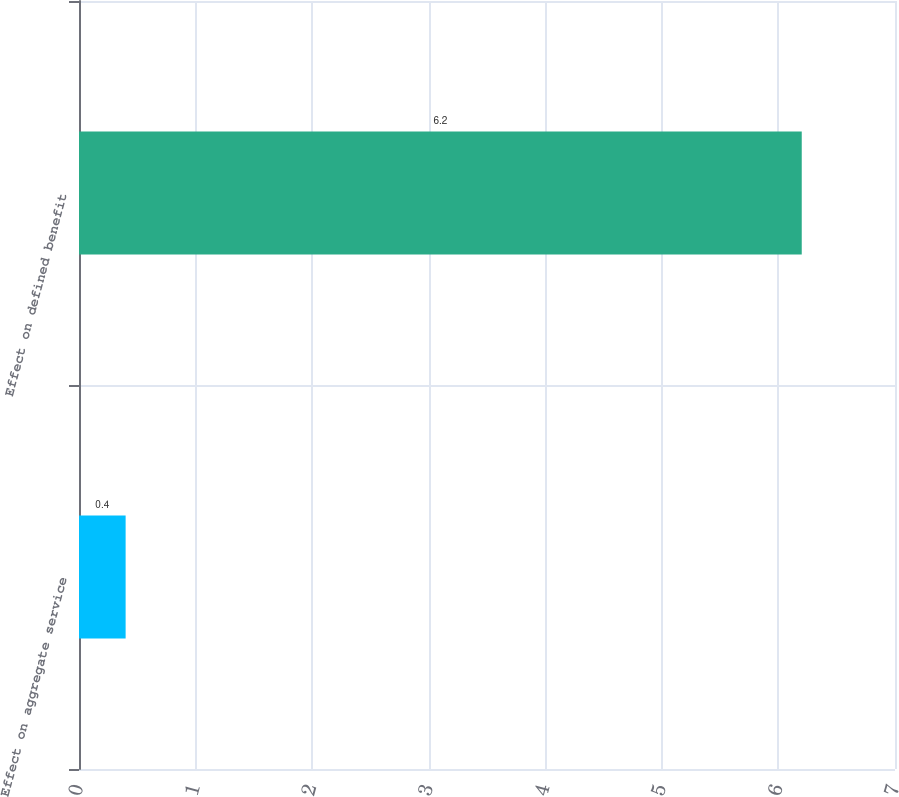Convert chart. <chart><loc_0><loc_0><loc_500><loc_500><bar_chart><fcel>Effect on aggregate service<fcel>Effect on defined benefit<nl><fcel>0.4<fcel>6.2<nl></chart> 